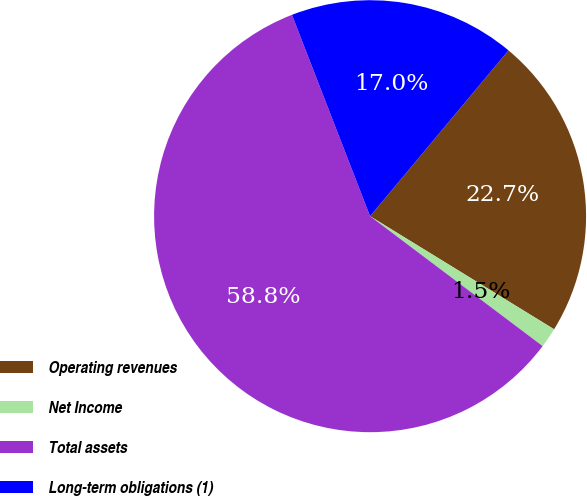Convert chart. <chart><loc_0><loc_0><loc_500><loc_500><pie_chart><fcel>Operating revenues<fcel>Net Income<fcel>Total assets<fcel>Long-term obligations (1)<nl><fcel>22.7%<fcel>1.5%<fcel>58.84%<fcel>16.96%<nl></chart> 